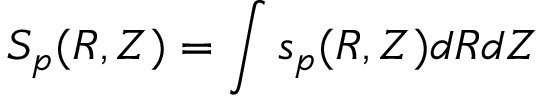<formula> <loc_0><loc_0><loc_500><loc_500>S _ { p } ( R , Z ) = \int s _ { p } ( R , Z ) d R d Z</formula> 